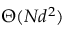Convert formula to latex. <formula><loc_0><loc_0><loc_500><loc_500>\Theta ( N d ^ { 2 } )</formula> 